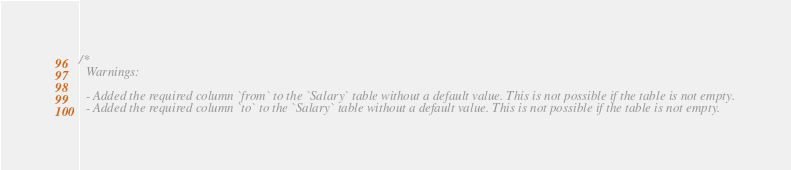<code> <loc_0><loc_0><loc_500><loc_500><_SQL_>/*
  Warnings:

  - Added the required column `from` to the `Salary` table without a default value. This is not possible if the table is not empty.
  - Added the required column `to` to the `Salary` table without a default value. This is not possible if the table is not empty.</code> 